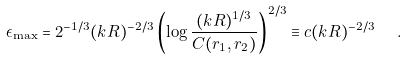<formula> <loc_0><loc_0><loc_500><loc_500>\epsilon _ { \max } = 2 ^ { - 1 / 3 } ( k R ) ^ { - 2 / 3 } \left ( \log \frac { ( k R ) ^ { 1 / 3 } } { C ( r _ { 1 } , r _ { 2 } ) } \right ) ^ { 2 / 3 } \equiv c ( k R ) ^ { - 2 / 3 } \ \ .</formula> 